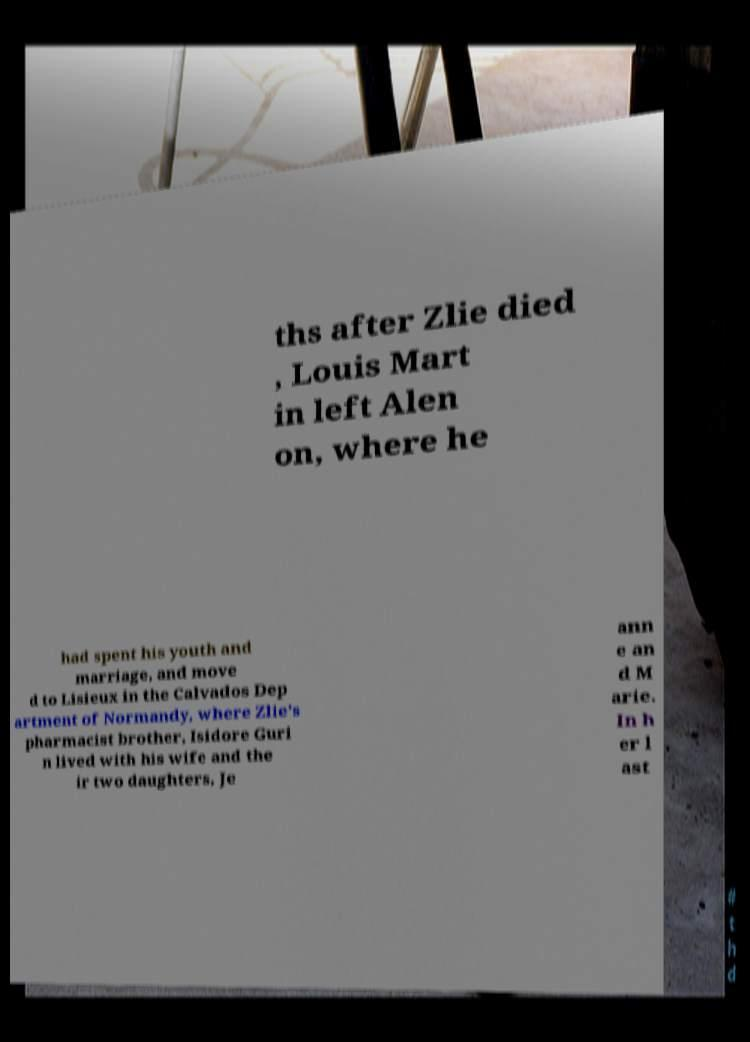Can you read and provide the text displayed in the image?This photo seems to have some interesting text. Can you extract and type it out for me? ths after Zlie died , Louis Mart in left Alen on, where he had spent his youth and marriage, and move d to Lisieux in the Calvados Dep artment of Normandy, where Zlie's pharmacist brother, Isidore Guri n lived with his wife and the ir two daughters, Je ann e an d M arie. In h er l ast 